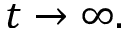Convert formula to latex. <formula><loc_0><loc_0><loc_500><loc_500>t \rightarrow \infty .</formula> 